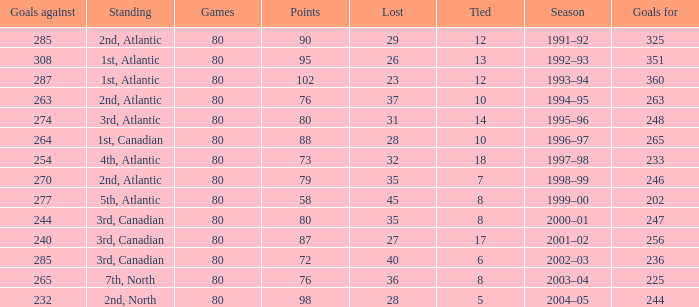How many goals against have 58 points? 277.0. 